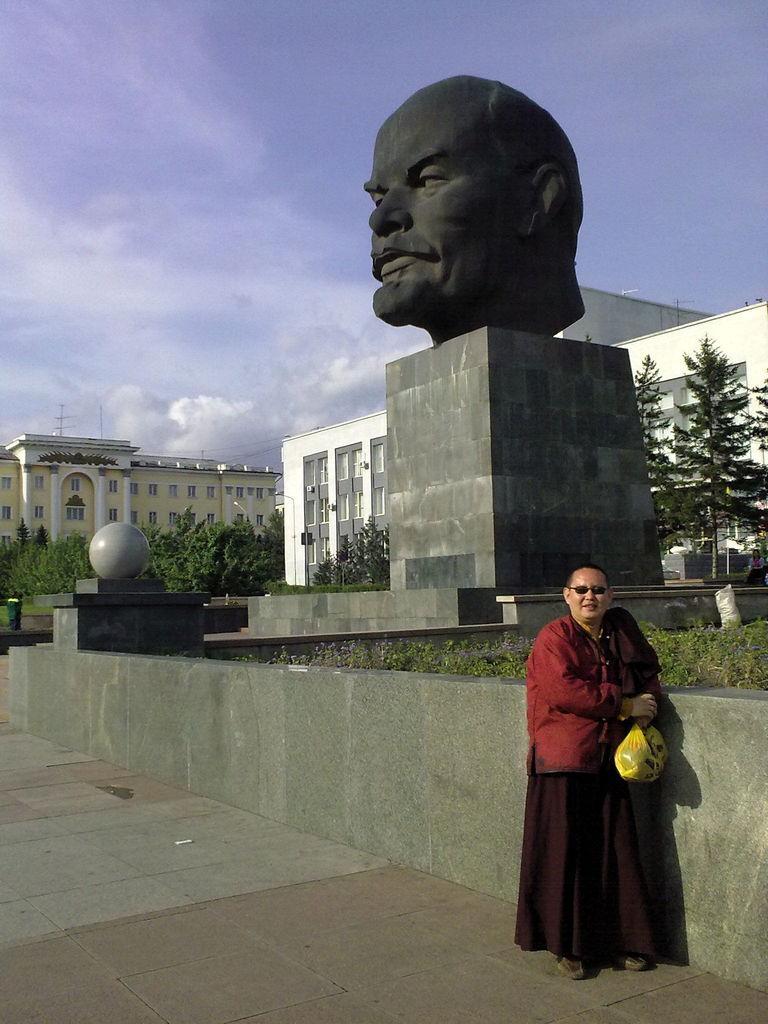Please provide a concise description of this image. In this image there is a sculptor, there is a person holding an object,there are buildings,there are trees, there is sky. 